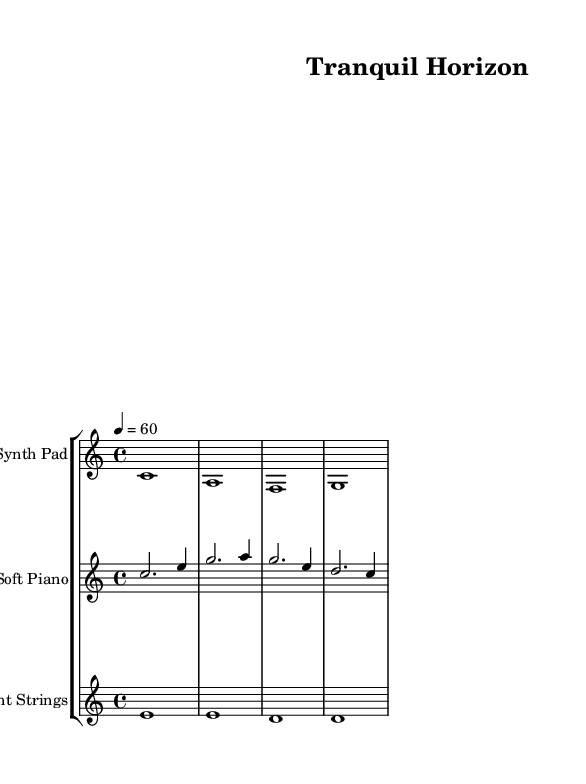What is the key signature of this music? The key signature is specified as C major, which contains no sharps or flats. This can be identified by looking for the absence of sharps or flats in the key signature section at the beginning of the score.
Answer: C major What is the time signature of this music? The indicated time signature is 4/4, which means there are four beats per measure and the quarter note gets one beat. This can be deduced from the 'time' declaration in the global settings of the score.
Answer: 4/4 What is the tempo marking of this piece? The tempo marking is set at 60 beats per minute. This information is found next to the tempo directive, which states the metronomic speed for performance.
Answer: 60 How many measures are there in the score? To determine the number of measures, we count the distinct vertical lines that separate the bars in the staff, which totals to four measures in this particular score segment.
Answer: 4 What instruments are included in this music? The score identifies three instruments: Synth Pad, Soft Piano, and Ambient Strings. Each is indicated in the staff headings, allowing us to know the different timbres present in the piece.
Answer: Synth Pad, Soft Piano, Ambient Strings What is the highest note in the Synth Pad part? The highest note in the Synth Pad part is C in the first measure. By scanning through the notes written in the Synth Pad staff, C is the highest note amongst the rest which are A, F, and G.
Answer: C What kind of musical style does this sheet music represent? This sheet music represents the ambient electronic style, evident by its soothing, slow tempo, and harmonizing chords that contribute to relaxation and meditation. The use of synthesizers and soft piano further emphasizes this genre.
Answer: Ambient electronic 